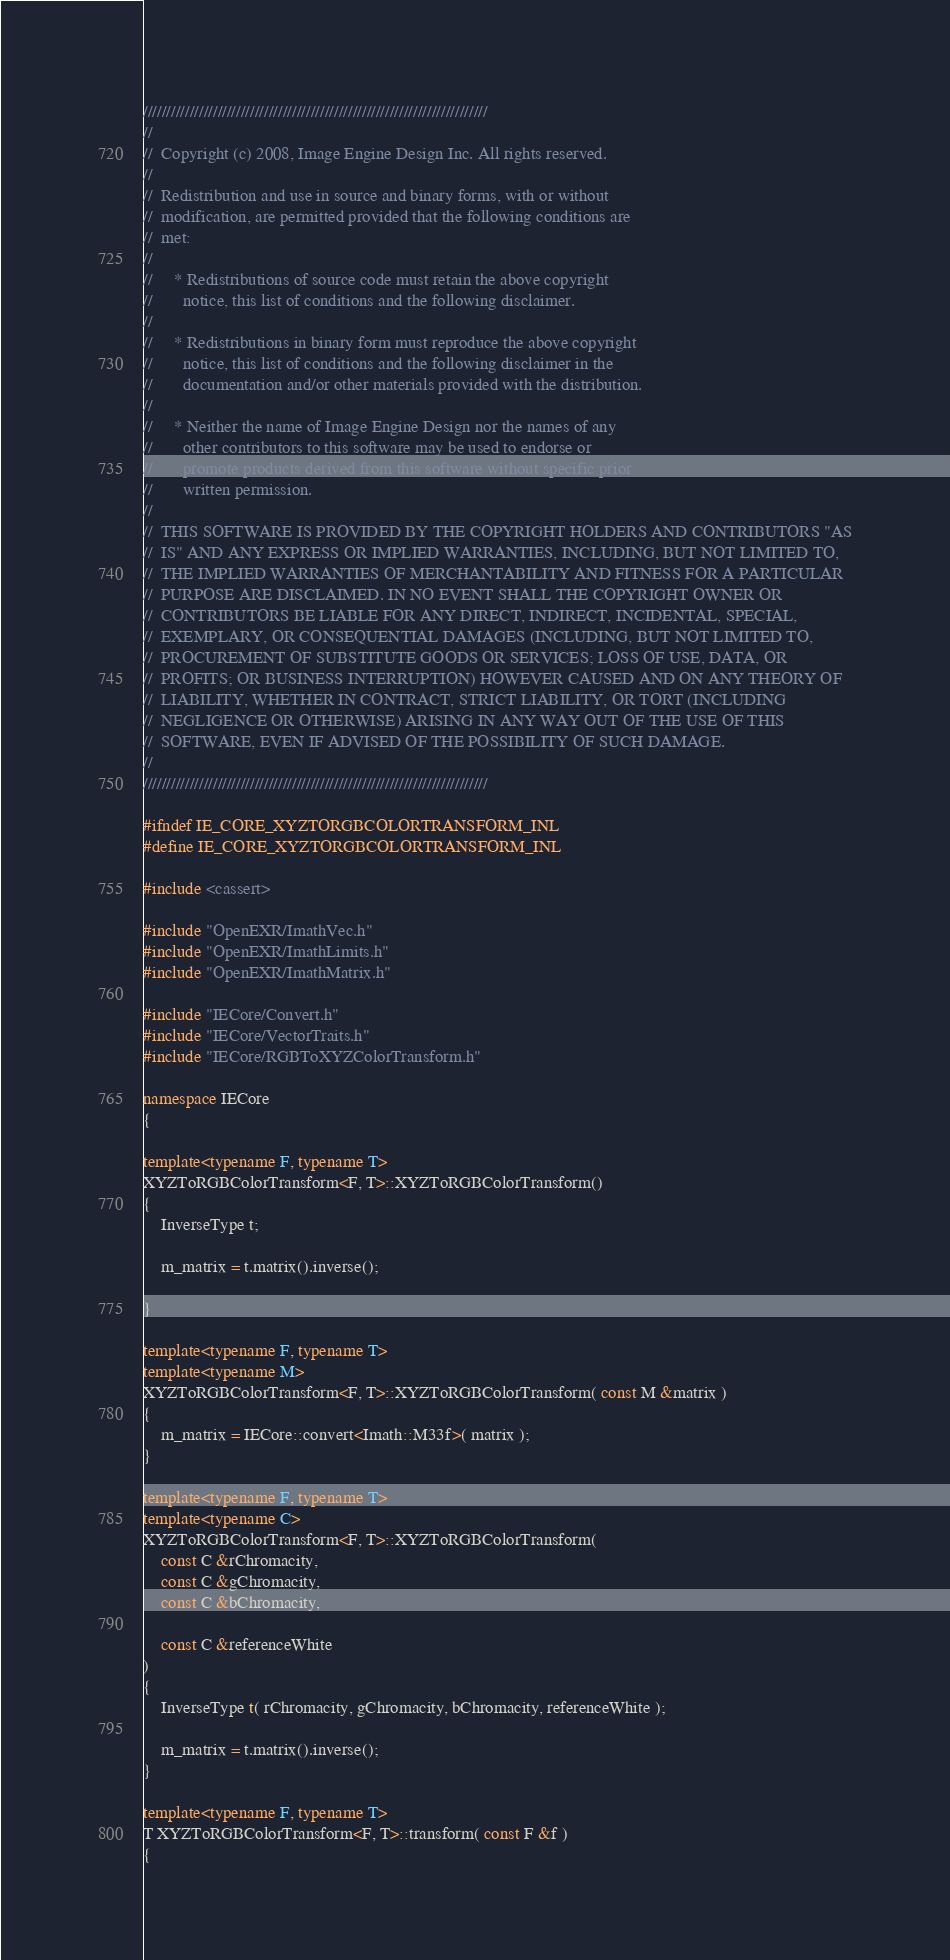<code> <loc_0><loc_0><loc_500><loc_500><_C++_>//////////////////////////////////////////////////////////////////////////
//
//  Copyright (c) 2008, Image Engine Design Inc. All rights reserved.
//
//  Redistribution and use in source and binary forms, with or without
//  modification, are permitted provided that the following conditions are
//  met:
//
//     * Redistributions of source code must retain the above copyright
//       notice, this list of conditions and the following disclaimer.
//
//     * Redistributions in binary form must reproduce the above copyright
//       notice, this list of conditions and the following disclaimer in the
//       documentation and/or other materials provided with the distribution.
//
//     * Neither the name of Image Engine Design nor the names of any
//       other contributors to this software may be used to endorse or
//       promote products derived from this software without specific prior
//       written permission.
//
//  THIS SOFTWARE IS PROVIDED BY THE COPYRIGHT HOLDERS AND CONTRIBUTORS "AS
//  IS" AND ANY EXPRESS OR IMPLIED WARRANTIES, INCLUDING, BUT NOT LIMITED TO,
//  THE IMPLIED WARRANTIES OF MERCHANTABILITY AND FITNESS FOR A PARTICULAR
//  PURPOSE ARE DISCLAIMED. IN NO EVENT SHALL THE COPYRIGHT OWNER OR
//  CONTRIBUTORS BE LIABLE FOR ANY DIRECT, INDIRECT, INCIDENTAL, SPECIAL,
//  EXEMPLARY, OR CONSEQUENTIAL DAMAGES (INCLUDING, BUT NOT LIMITED TO,
//  PROCUREMENT OF SUBSTITUTE GOODS OR SERVICES; LOSS OF USE, DATA, OR
//  PROFITS; OR BUSINESS INTERRUPTION) HOWEVER CAUSED AND ON ANY THEORY OF
//  LIABILITY, WHETHER IN CONTRACT, STRICT LIABILITY, OR TORT (INCLUDING
//  NEGLIGENCE OR OTHERWISE) ARISING IN ANY WAY OUT OF THE USE OF THIS
//  SOFTWARE, EVEN IF ADVISED OF THE POSSIBILITY OF SUCH DAMAGE.
//
//////////////////////////////////////////////////////////////////////////

#ifndef IE_CORE_XYZTORGBCOLORTRANSFORM_INL
#define IE_CORE_XYZTORGBCOLORTRANSFORM_INL

#include <cassert>

#include "OpenEXR/ImathVec.h"
#include "OpenEXR/ImathLimits.h"
#include "OpenEXR/ImathMatrix.h"

#include "IECore/Convert.h"
#include "IECore/VectorTraits.h"
#include "IECore/RGBToXYZColorTransform.h"

namespace IECore
{

template<typename F, typename T>
XYZToRGBColorTransform<F, T>::XYZToRGBColorTransform()
{
	InverseType t;

	m_matrix = t.matrix().inverse();

}

template<typename F, typename T>
template<typename M>
XYZToRGBColorTransform<F, T>::XYZToRGBColorTransform( const M &matrix )
{
	m_matrix = IECore::convert<Imath::M33f>( matrix );
}

template<typename F, typename T>
template<typename C>
XYZToRGBColorTransform<F, T>::XYZToRGBColorTransform(
	const C &rChromacity,
	const C &gChromacity,
	const C &bChromacity,

	const C &referenceWhite
)
{
	InverseType t( rChromacity, gChromacity, bChromacity, referenceWhite );

	m_matrix = t.matrix().inverse();
}

template<typename F, typename T>
T XYZToRGBColorTransform<F, T>::transform( const F &f )
{</code> 